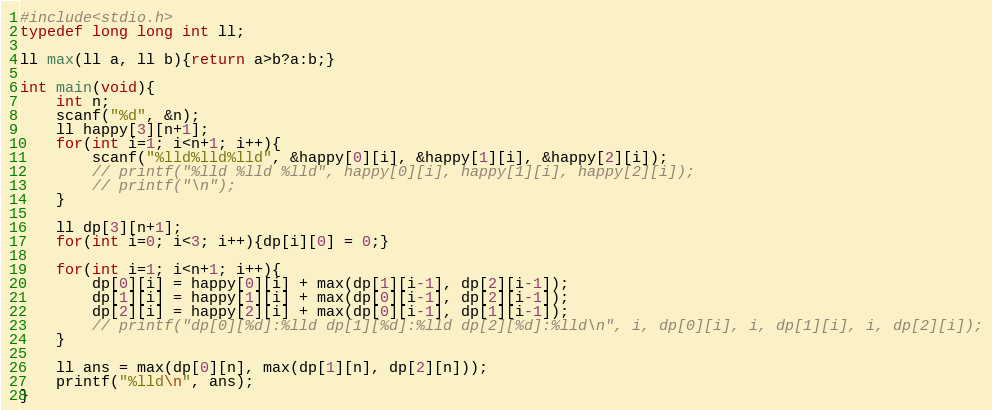Convert code to text. <code><loc_0><loc_0><loc_500><loc_500><_C_>#include<stdio.h>
typedef long long int ll;

ll max(ll a, ll b){return a>b?a:b;}

int main(void){
    int n;
    scanf("%d", &n);
    ll happy[3][n+1];
    for(int i=1; i<n+1; i++){
        scanf("%lld%lld%lld", &happy[0][i], &happy[1][i], &happy[2][i]);
        // printf("%lld %lld %lld", happy[0][i], happy[1][i], happy[2][i]);
        // printf("\n");
    }

    ll dp[3][n+1];
    for(int i=0; i<3; i++){dp[i][0] = 0;}

    for(int i=1; i<n+1; i++){
        dp[0][i] = happy[0][i] + max(dp[1][i-1], dp[2][i-1]);
        dp[1][i] = happy[1][i] + max(dp[0][i-1], dp[2][i-1]);
        dp[2][i] = happy[2][i] + max(dp[0][i-1], dp[1][i-1]);
        // printf("dp[0][%d]:%lld dp[1][%d]:%lld dp[2][%d]:%lld\n", i, dp[0][i], i, dp[1][i], i, dp[2][i]);
    }

    ll ans = max(dp[0][n], max(dp[1][n], dp[2][n]));
    printf("%lld\n", ans);
}</code> 